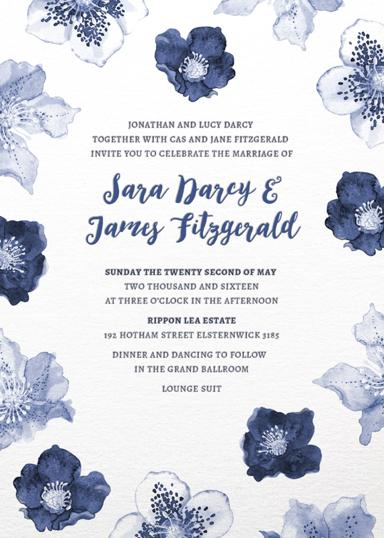What style and theme does the wedding invitation suggest? The wedding invitation suggests an elegant and floral theme, highlighted by beautiful watercolor blue flowers and delicate script fonts, indicating a refined yet intimate celebration atmosphere. 